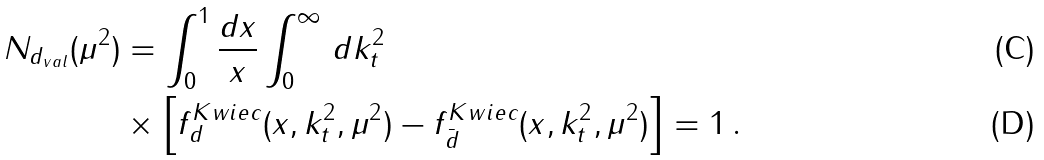<formula> <loc_0><loc_0><loc_500><loc_500>N _ { d _ { v a l } } ( \mu ^ { 2 } ) & = \int _ { 0 } ^ { 1 } \frac { d x } { x } \int _ { 0 } ^ { \infty } \, d k _ { t } ^ { 2 } \\ & \times \left [ f _ { d } ^ { K w i e c } ( x , k _ { t } ^ { 2 } , \mu ^ { 2 } ) - f _ { \bar { d } } ^ { K w i e c } ( x , k _ { t } ^ { 2 } , \mu ^ { 2 } ) \right ] = 1 \, .</formula> 